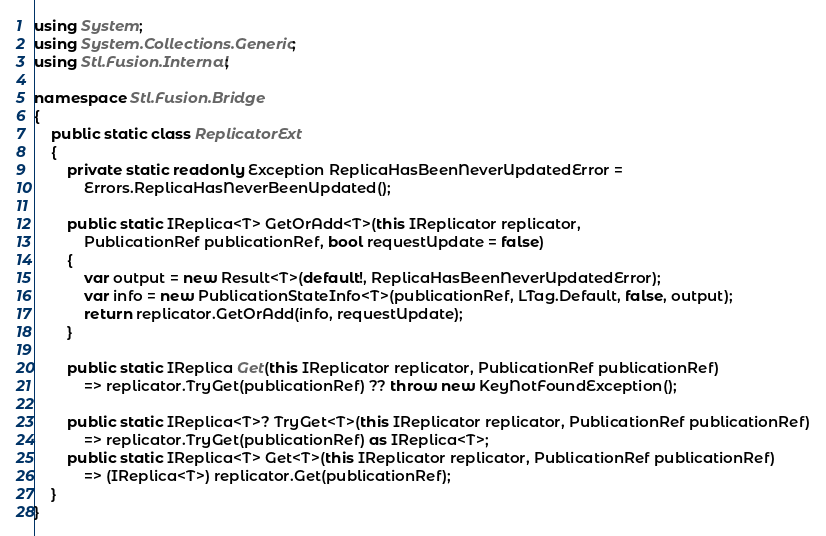<code> <loc_0><loc_0><loc_500><loc_500><_C#_>using System;
using System.Collections.Generic;
using Stl.Fusion.Internal;

namespace Stl.Fusion.Bridge
{
    public static class ReplicatorExt
    {
        private static readonly Exception ReplicaHasBeenNeverUpdatedError =
            Errors.ReplicaHasNeverBeenUpdated();

        public static IReplica<T> GetOrAdd<T>(this IReplicator replicator,
            PublicationRef publicationRef, bool requestUpdate = false)
        {
            var output = new Result<T>(default!, ReplicaHasBeenNeverUpdatedError);
            var info = new PublicationStateInfo<T>(publicationRef, LTag.Default, false, output);
            return replicator.GetOrAdd(info, requestUpdate);
        }

        public static IReplica Get(this IReplicator replicator, PublicationRef publicationRef)
            => replicator.TryGet(publicationRef) ?? throw new KeyNotFoundException();

        public static IReplica<T>? TryGet<T>(this IReplicator replicator, PublicationRef publicationRef)
            => replicator.TryGet(publicationRef) as IReplica<T>;
        public static IReplica<T> Get<T>(this IReplicator replicator, PublicationRef publicationRef)
            => (IReplica<T>) replicator.Get(publicationRef);
    }
}
</code> 